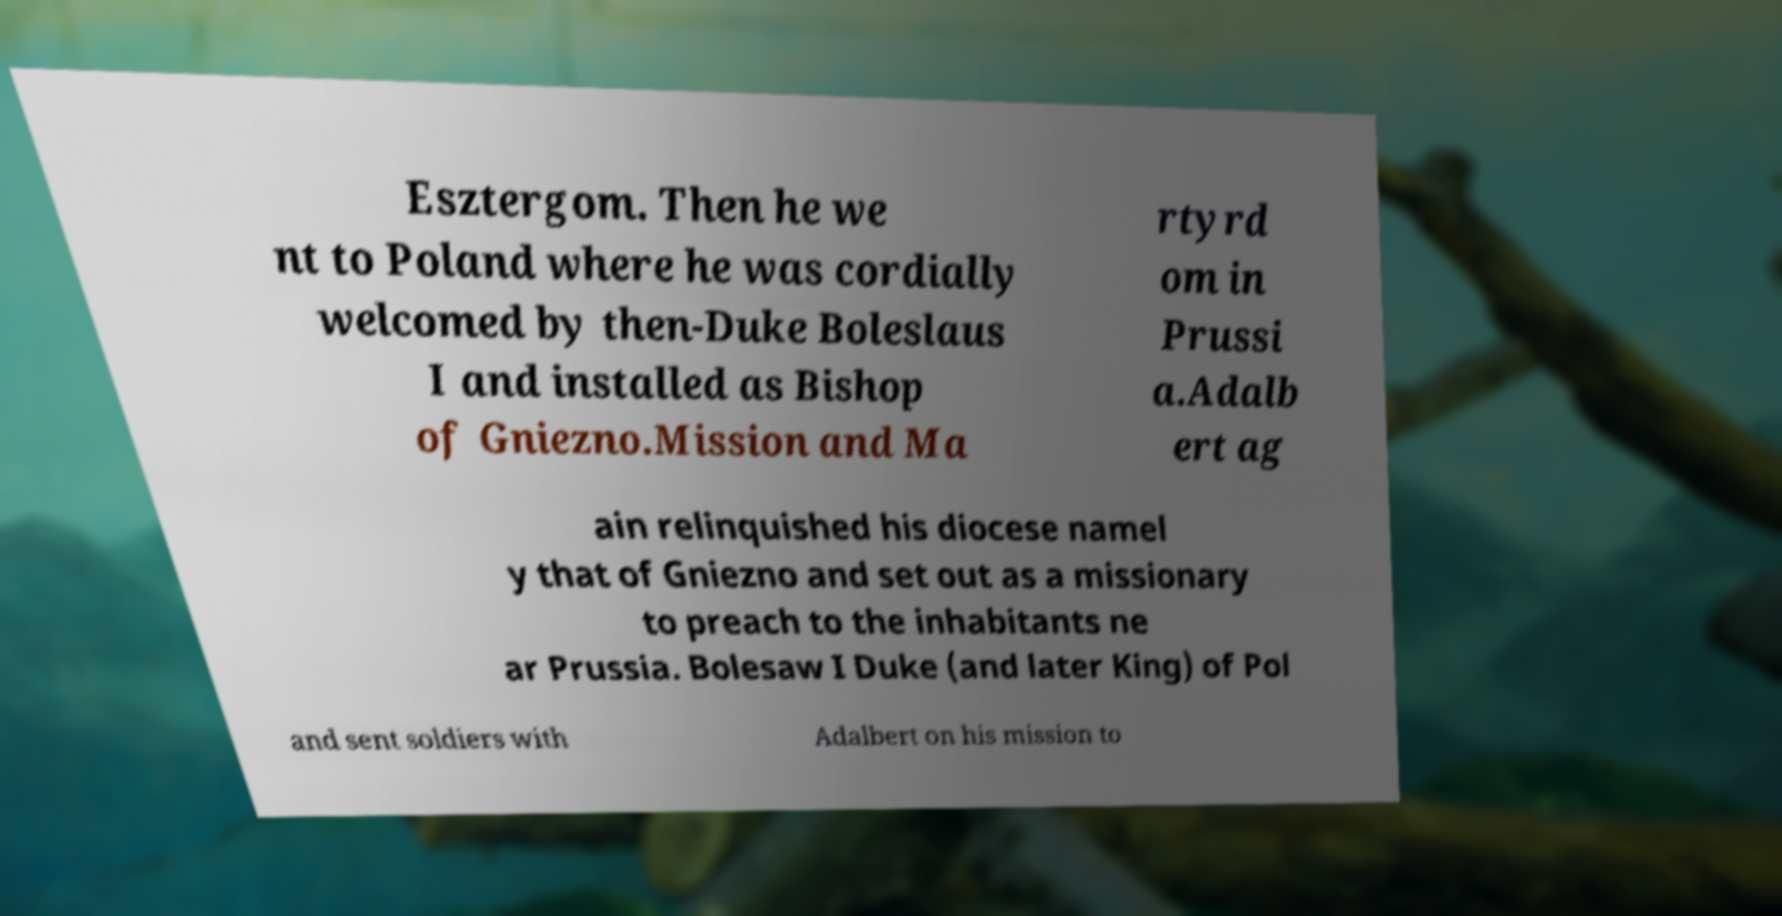Could you assist in decoding the text presented in this image and type it out clearly? Esztergom. Then he we nt to Poland where he was cordially welcomed by then-Duke Boleslaus I and installed as Bishop of Gniezno.Mission and Ma rtyrd om in Prussi a.Adalb ert ag ain relinquished his diocese namel y that of Gniezno and set out as a missionary to preach to the inhabitants ne ar Prussia. Bolesaw I Duke (and later King) of Pol and sent soldiers with Adalbert on his mission to 